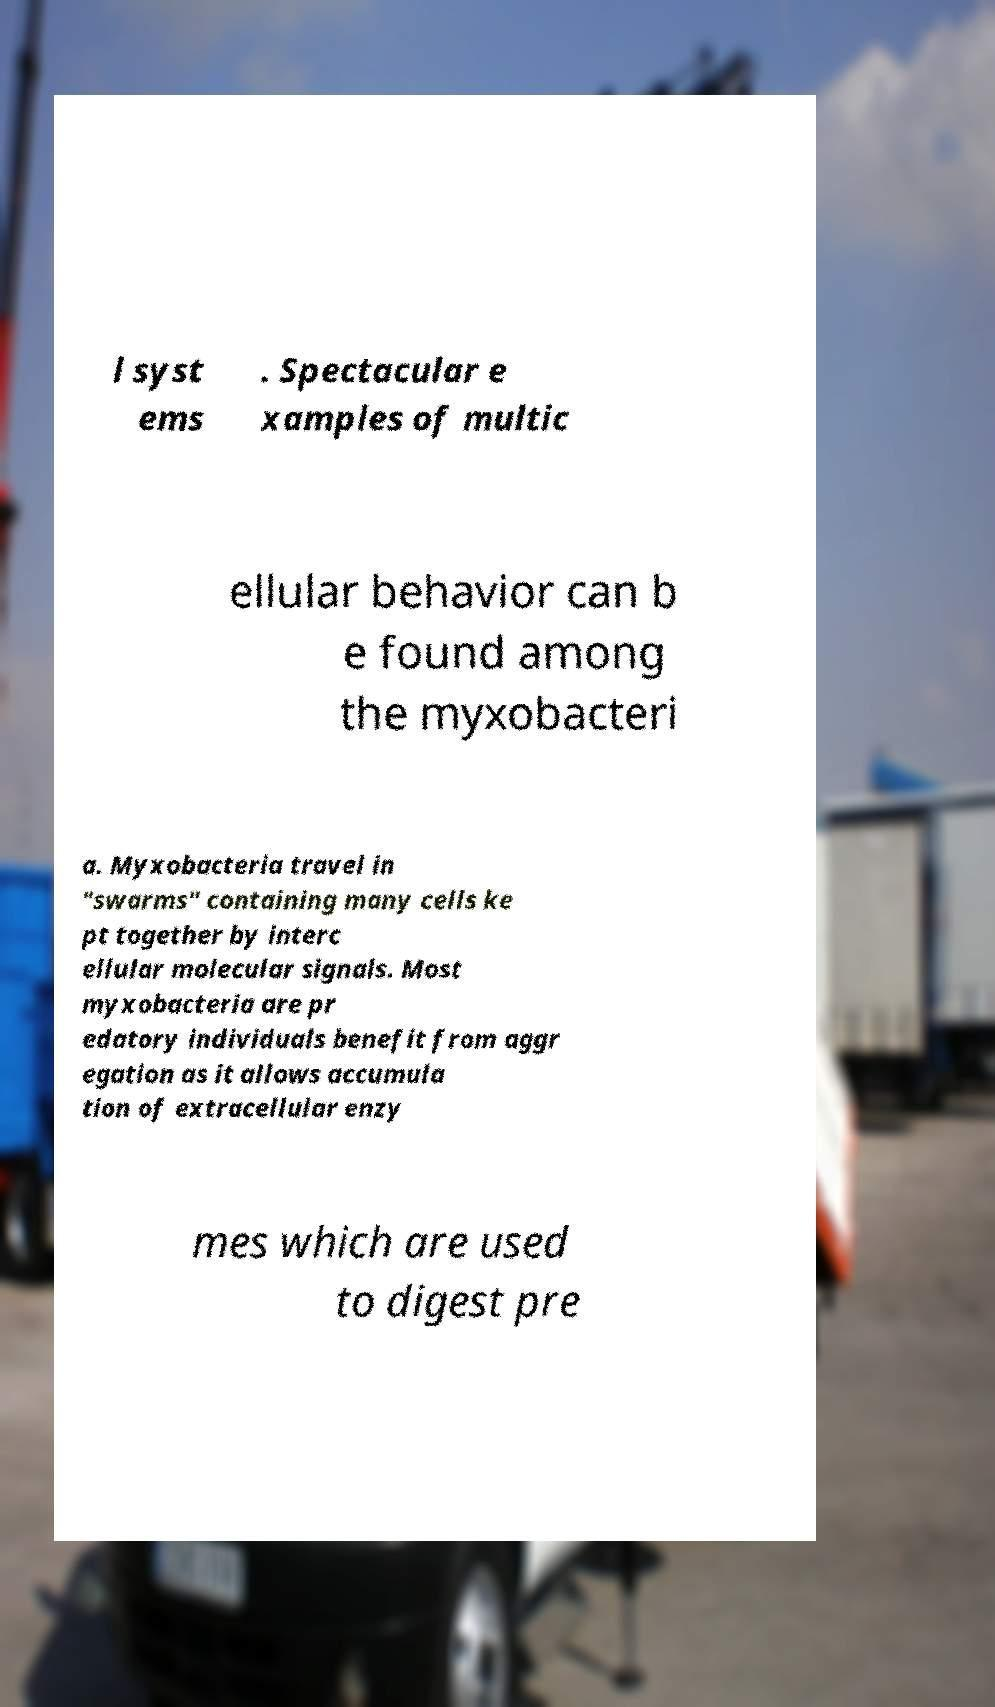Can you read and provide the text displayed in the image?This photo seems to have some interesting text. Can you extract and type it out for me? l syst ems . Spectacular e xamples of multic ellular behavior can b e found among the myxobacteri a. Myxobacteria travel in "swarms" containing many cells ke pt together by interc ellular molecular signals. Most myxobacteria are pr edatory individuals benefit from aggr egation as it allows accumula tion of extracellular enzy mes which are used to digest pre 